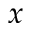<formula> <loc_0><loc_0><loc_500><loc_500>x</formula> 